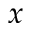<formula> <loc_0><loc_0><loc_500><loc_500>x</formula> 